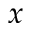<formula> <loc_0><loc_0><loc_500><loc_500>x</formula> 